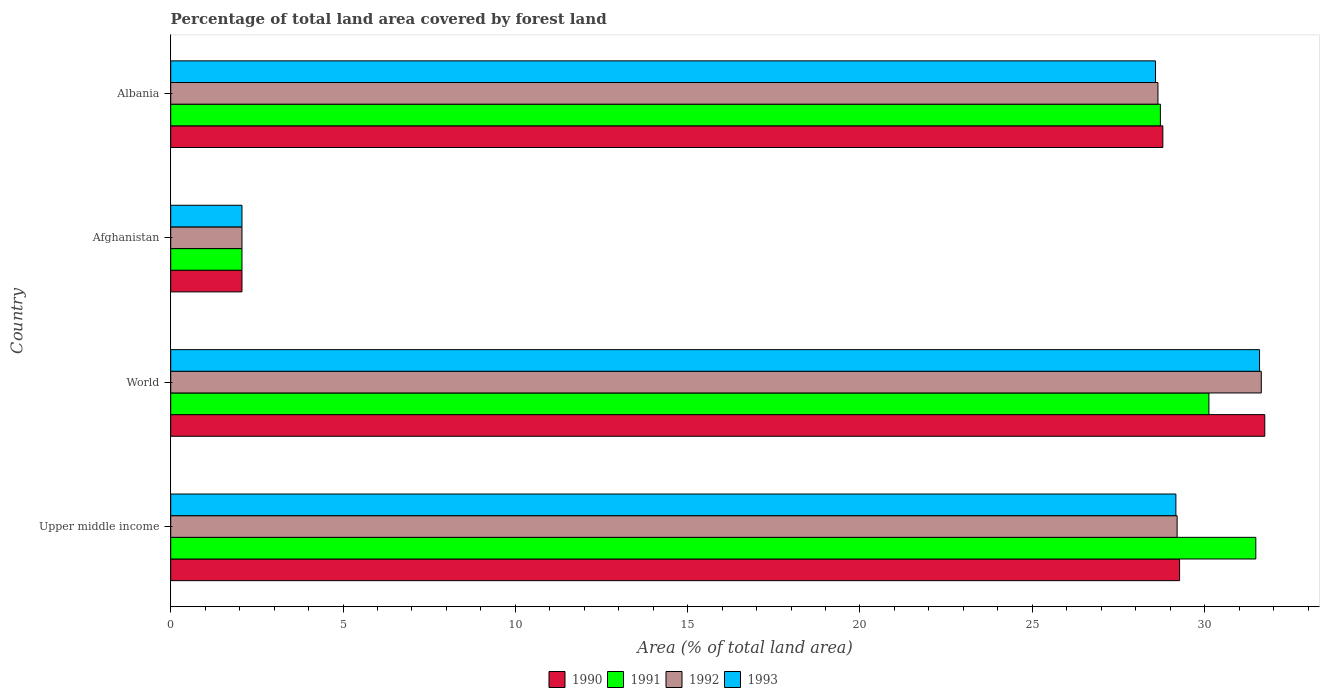How many bars are there on the 1st tick from the bottom?
Keep it short and to the point. 4. What is the label of the 4th group of bars from the top?
Keep it short and to the point. Upper middle income. What is the percentage of forest land in 1992 in World?
Your response must be concise. 31.64. Across all countries, what is the maximum percentage of forest land in 1991?
Ensure brevity in your answer.  31.49. Across all countries, what is the minimum percentage of forest land in 1991?
Give a very brief answer. 2.07. In which country was the percentage of forest land in 1993 maximum?
Provide a short and direct response. World. In which country was the percentage of forest land in 1992 minimum?
Offer a very short reply. Afghanistan. What is the total percentage of forest land in 1993 in the graph?
Keep it short and to the point. 91.4. What is the difference between the percentage of forest land in 1993 in Afghanistan and that in Albania?
Offer a terse response. -26.51. What is the difference between the percentage of forest land in 1992 in Albania and the percentage of forest land in 1991 in World?
Provide a short and direct response. -1.48. What is the average percentage of forest land in 1992 per country?
Your answer should be compact. 22.89. What is the difference between the percentage of forest land in 1991 and percentage of forest land in 1993 in Upper middle income?
Offer a terse response. 2.32. What is the ratio of the percentage of forest land in 1991 in Upper middle income to that in World?
Provide a succinct answer. 1.05. What is the difference between the highest and the second highest percentage of forest land in 1991?
Keep it short and to the point. 1.36. What is the difference between the highest and the lowest percentage of forest land in 1992?
Keep it short and to the point. 29.58. In how many countries, is the percentage of forest land in 1990 greater than the average percentage of forest land in 1990 taken over all countries?
Provide a short and direct response. 3. What does the 1st bar from the top in Afghanistan represents?
Offer a terse response. 1993. What does the 1st bar from the bottom in Albania represents?
Ensure brevity in your answer.  1990. How many bars are there?
Your answer should be very brief. 16. What is the difference between two consecutive major ticks on the X-axis?
Provide a short and direct response. 5. Are the values on the major ticks of X-axis written in scientific E-notation?
Make the answer very short. No. Does the graph contain grids?
Give a very brief answer. No. How are the legend labels stacked?
Your response must be concise. Horizontal. What is the title of the graph?
Offer a very short reply. Percentage of total land area covered by forest land. What is the label or title of the X-axis?
Keep it short and to the point. Area (% of total land area). What is the Area (% of total land area) in 1990 in Upper middle income?
Your answer should be compact. 29.27. What is the Area (% of total land area) in 1991 in Upper middle income?
Provide a short and direct response. 31.49. What is the Area (% of total land area) in 1992 in Upper middle income?
Offer a very short reply. 29.2. What is the Area (% of total land area) of 1993 in Upper middle income?
Give a very brief answer. 29.17. What is the Area (% of total land area) in 1990 in World?
Keep it short and to the point. 31.75. What is the Area (% of total land area) in 1991 in World?
Your answer should be very brief. 30.12. What is the Area (% of total land area) in 1992 in World?
Give a very brief answer. 31.64. What is the Area (% of total land area) of 1993 in World?
Provide a short and direct response. 31.59. What is the Area (% of total land area) of 1990 in Afghanistan?
Your answer should be compact. 2.07. What is the Area (% of total land area) of 1991 in Afghanistan?
Provide a succinct answer. 2.07. What is the Area (% of total land area) in 1992 in Afghanistan?
Give a very brief answer. 2.07. What is the Area (% of total land area) of 1993 in Afghanistan?
Provide a succinct answer. 2.07. What is the Area (% of total land area) in 1990 in Albania?
Offer a terse response. 28.79. What is the Area (% of total land area) in 1991 in Albania?
Offer a very short reply. 28.72. What is the Area (% of total land area) of 1992 in Albania?
Offer a very short reply. 28.65. What is the Area (% of total land area) of 1993 in Albania?
Make the answer very short. 28.57. Across all countries, what is the maximum Area (% of total land area) of 1990?
Provide a short and direct response. 31.75. Across all countries, what is the maximum Area (% of total land area) in 1991?
Offer a very short reply. 31.49. Across all countries, what is the maximum Area (% of total land area) in 1992?
Make the answer very short. 31.64. Across all countries, what is the maximum Area (% of total land area) in 1993?
Your response must be concise. 31.59. Across all countries, what is the minimum Area (% of total land area) in 1990?
Provide a short and direct response. 2.07. Across all countries, what is the minimum Area (% of total land area) in 1991?
Ensure brevity in your answer.  2.07. Across all countries, what is the minimum Area (% of total land area) of 1992?
Offer a very short reply. 2.07. Across all countries, what is the minimum Area (% of total land area) in 1993?
Offer a very short reply. 2.07. What is the total Area (% of total land area) in 1990 in the graph?
Your answer should be very brief. 91.88. What is the total Area (% of total land area) of 1991 in the graph?
Provide a short and direct response. 92.4. What is the total Area (% of total land area) of 1992 in the graph?
Offer a very short reply. 91.56. What is the total Area (% of total land area) of 1993 in the graph?
Offer a very short reply. 91.4. What is the difference between the Area (% of total land area) in 1990 in Upper middle income and that in World?
Make the answer very short. -2.47. What is the difference between the Area (% of total land area) in 1991 in Upper middle income and that in World?
Your answer should be very brief. 1.36. What is the difference between the Area (% of total land area) of 1992 in Upper middle income and that in World?
Offer a very short reply. -2.44. What is the difference between the Area (% of total land area) of 1993 in Upper middle income and that in World?
Make the answer very short. -2.43. What is the difference between the Area (% of total land area) of 1990 in Upper middle income and that in Afghanistan?
Give a very brief answer. 27.21. What is the difference between the Area (% of total land area) of 1991 in Upper middle income and that in Afghanistan?
Offer a terse response. 29.42. What is the difference between the Area (% of total land area) of 1992 in Upper middle income and that in Afghanistan?
Make the answer very short. 27.13. What is the difference between the Area (% of total land area) in 1993 in Upper middle income and that in Afghanistan?
Ensure brevity in your answer.  27.1. What is the difference between the Area (% of total land area) of 1990 in Upper middle income and that in Albania?
Make the answer very short. 0.49. What is the difference between the Area (% of total land area) of 1991 in Upper middle income and that in Albania?
Give a very brief answer. 2.77. What is the difference between the Area (% of total land area) of 1992 in Upper middle income and that in Albania?
Offer a very short reply. 0.56. What is the difference between the Area (% of total land area) in 1993 in Upper middle income and that in Albania?
Provide a succinct answer. 0.59. What is the difference between the Area (% of total land area) in 1990 in World and that in Afghanistan?
Offer a very short reply. 29.68. What is the difference between the Area (% of total land area) of 1991 in World and that in Afghanistan?
Keep it short and to the point. 28.06. What is the difference between the Area (% of total land area) of 1992 in World and that in Afghanistan?
Ensure brevity in your answer.  29.58. What is the difference between the Area (% of total land area) of 1993 in World and that in Afghanistan?
Ensure brevity in your answer.  29.53. What is the difference between the Area (% of total land area) in 1990 in World and that in Albania?
Your answer should be very brief. 2.96. What is the difference between the Area (% of total land area) in 1991 in World and that in Albania?
Offer a terse response. 1.41. What is the difference between the Area (% of total land area) of 1992 in World and that in Albania?
Your response must be concise. 3. What is the difference between the Area (% of total land area) in 1993 in World and that in Albania?
Make the answer very short. 3.02. What is the difference between the Area (% of total land area) in 1990 in Afghanistan and that in Albania?
Keep it short and to the point. -26.72. What is the difference between the Area (% of total land area) in 1991 in Afghanistan and that in Albania?
Offer a terse response. -26.65. What is the difference between the Area (% of total land area) of 1992 in Afghanistan and that in Albania?
Offer a very short reply. -26.58. What is the difference between the Area (% of total land area) in 1993 in Afghanistan and that in Albania?
Provide a short and direct response. -26.51. What is the difference between the Area (% of total land area) in 1990 in Upper middle income and the Area (% of total land area) in 1991 in World?
Your response must be concise. -0.85. What is the difference between the Area (% of total land area) in 1990 in Upper middle income and the Area (% of total land area) in 1992 in World?
Make the answer very short. -2.37. What is the difference between the Area (% of total land area) of 1990 in Upper middle income and the Area (% of total land area) of 1993 in World?
Your response must be concise. -2.32. What is the difference between the Area (% of total land area) in 1991 in Upper middle income and the Area (% of total land area) in 1992 in World?
Offer a very short reply. -0.16. What is the difference between the Area (% of total land area) in 1991 in Upper middle income and the Area (% of total land area) in 1993 in World?
Ensure brevity in your answer.  -0.11. What is the difference between the Area (% of total land area) in 1992 in Upper middle income and the Area (% of total land area) in 1993 in World?
Your answer should be compact. -2.39. What is the difference between the Area (% of total land area) of 1990 in Upper middle income and the Area (% of total land area) of 1991 in Afghanistan?
Your answer should be compact. 27.21. What is the difference between the Area (% of total land area) in 1990 in Upper middle income and the Area (% of total land area) in 1992 in Afghanistan?
Your answer should be compact. 27.21. What is the difference between the Area (% of total land area) of 1990 in Upper middle income and the Area (% of total land area) of 1993 in Afghanistan?
Your answer should be very brief. 27.21. What is the difference between the Area (% of total land area) of 1991 in Upper middle income and the Area (% of total land area) of 1992 in Afghanistan?
Your answer should be compact. 29.42. What is the difference between the Area (% of total land area) of 1991 in Upper middle income and the Area (% of total land area) of 1993 in Afghanistan?
Offer a very short reply. 29.42. What is the difference between the Area (% of total land area) of 1992 in Upper middle income and the Area (% of total land area) of 1993 in Afghanistan?
Your answer should be compact. 27.13. What is the difference between the Area (% of total land area) of 1990 in Upper middle income and the Area (% of total land area) of 1991 in Albania?
Keep it short and to the point. 0.56. What is the difference between the Area (% of total land area) in 1990 in Upper middle income and the Area (% of total land area) in 1992 in Albania?
Your response must be concise. 0.63. What is the difference between the Area (% of total land area) in 1990 in Upper middle income and the Area (% of total land area) in 1993 in Albania?
Give a very brief answer. 0.7. What is the difference between the Area (% of total land area) in 1991 in Upper middle income and the Area (% of total land area) in 1992 in Albania?
Give a very brief answer. 2.84. What is the difference between the Area (% of total land area) in 1991 in Upper middle income and the Area (% of total land area) in 1993 in Albania?
Your answer should be compact. 2.91. What is the difference between the Area (% of total land area) in 1992 in Upper middle income and the Area (% of total land area) in 1993 in Albania?
Keep it short and to the point. 0.63. What is the difference between the Area (% of total land area) of 1990 in World and the Area (% of total land area) of 1991 in Afghanistan?
Your response must be concise. 29.68. What is the difference between the Area (% of total land area) of 1990 in World and the Area (% of total land area) of 1992 in Afghanistan?
Ensure brevity in your answer.  29.68. What is the difference between the Area (% of total land area) in 1990 in World and the Area (% of total land area) in 1993 in Afghanistan?
Your answer should be very brief. 29.68. What is the difference between the Area (% of total land area) of 1991 in World and the Area (% of total land area) of 1992 in Afghanistan?
Offer a terse response. 28.06. What is the difference between the Area (% of total land area) in 1991 in World and the Area (% of total land area) in 1993 in Afghanistan?
Provide a short and direct response. 28.06. What is the difference between the Area (% of total land area) of 1992 in World and the Area (% of total land area) of 1993 in Afghanistan?
Make the answer very short. 29.58. What is the difference between the Area (% of total land area) in 1990 in World and the Area (% of total land area) in 1991 in Albania?
Your response must be concise. 3.03. What is the difference between the Area (% of total land area) of 1990 in World and the Area (% of total land area) of 1992 in Albania?
Keep it short and to the point. 3.1. What is the difference between the Area (% of total land area) in 1990 in World and the Area (% of total land area) in 1993 in Albania?
Your response must be concise. 3.17. What is the difference between the Area (% of total land area) of 1991 in World and the Area (% of total land area) of 1992 in Albania?
Give a very brief answer. 1.48. What is the difference between the Area (% of total land area) in 1991 in World and the Area (% of total land area) in 1993 in Albania?
Give a very brief answer. 1.55. What is the difference between the Area (% of total land area) of 1992 in World and the Area (% of total land area) of 1993 in Albania?
Offer a very short reply. 3.07. What is the difference between the Area (% of total land area) in 1990 in Afghanistan and the Area (% of total land area) in 1991 in Albania?
Ensure brevity in your answer.  -26.65. What is the difference between the Area (% of total land area) in 1990 in Afghanistan and the Area (% of total land area) in 1992 in Albania?
Your answer should be very brief. -26.58. What is the difference between the Area (% of total land area) of 1990 in Afghanistan and the Area (% of total land area) of 1993 in Albania?
Provide a succinct answer. -26.51. What is the difference between the Area (% of total land area) in 1991 in Afghanistan and the Area (% of total land area) in 1992 in Albania?
Ensure brevity in your answer.  -26.58. What is the difference between the Area (% of total land area) in 1991 in Afghanistan and the Area (% of total land area) in 1993 in Albania?
Offer a terse response. -26.51. What is the difference between the Area (% of total land area) of 1992 in Afghanistan and the Area (% of total land area) of 1993 in Albania?
Offer a very short reply. -26.51. What is the average Area (% of total land area) in 1990 per country?
Your answer should be compact. 22.97. What is the average Area (% of total land area) in 1991 per country?
Make the answer very short. 23.1. What is the average Area (% of total land area) of 1992 per country?
Keep it short and to the point. 22.89. What is the average Area (% of total land area) in 1993 per country?
Provide a succinct answer. 22.85. What is the difference between the Area (% of total land area) in 1990 and Area (% of total land area) in 1991 in Upper middle income?
Give a very brief answer. -2.21. What is the difference between the Area (% of total land area) in 1990 and Area (% of total land area) in 1992 in Upper middle income?
Give a very brief answer. 0.07. What is the difference between the Area (% of total land area) in 1990 and Area (% of total land area) in 1993 in Upper middle income?
Give a very brief answer. 0.11. What is the difference between the Area (% of total land area) in 1991 and Area (% of total land area) in 1992 in Upper middle income?
Your answer should be very brief. 2.28. What is the difference between the Area (% of total land area) in 1991 and Area (% of total land area) in 1993 in Upper middle income?
Your answer should be very brief. 2.32. What is the difference between the Area (% of total land area) in 1992 and Area (% of total land area) in 1993 in Upper middle income?
Your answer should be compact. 0.04. What is the difference between the Area (% of total land area) in 1990 and Area (% of total land area) in 1991 in World?
Keep it short and to the point. 1.62. What is the difference between the Area (% of total land area) of 1990 and Area (% of total land area) of 1992 in World?
Provide a succinct answer. 0.1. What is the difference between the Area (% of total land area) of 1990 and Area (% of total land area) of 1993 in World?
Your response must be concise. 0.15. What is the difference between the Area (% of total land area) of 1991 and Area (% of total land area) of 1992 in World?
Make the answer very short. -1.52. What is the difference between the Area (% of total land area) in 1991 and Area (% of total land area) in 1993 in World?
Ensure brevity in your answer.  -1.47. What is the difference between the Area (% of total land area) in 1992 and Area (% of total land area) in 1993 in World?
Offer a very short reply. 0.05. What is the difference between the Area (% of total land area) in 1990 and Area (% of total land area) in 1991 in Afghanistan?
Give a very brief answer. 0. What is the difference between the Area (% of total land area) of 1990 and Area (% of total land area) of 1992 in Afghanistan?
Keep it short and to the point. 0. What is the difference between the Area (% of total land area) of 1990 and Area (% of total land area) of 1993 in Afghanistan?
Offer a terse response. 0. What is the difference between the Area (% of total land area) of 1991 and Area (% of total land area) of 1992 in Afghanistan?
Provide a succinct answer. 0. What is the difference between the Area (% of total land area) in 1992 and Area (% of total land area) in 1993 in Afghanistan?
Offer a very short reply. 0. What is the difference between the Area (% of total land area) of 1990 and Area (% of total land area) of 1991 in Albania?
Make the answer very short. 0.07. What is the difference between the Area (% of total land area) in 1990 and Area (% of total land area) in 1992 in Albania?
Offer a very short reply. 0.14. What is the difference between the Area (% of total land area) of 1990 and Area (% of total land area) of 1993 in Albania?
Offer a terse response. 0.21. What is the difference between the Area (% of total land area) of 1991 and Area (% of total land area) of 1992 in Albania?
Your answer should be compact. 0.07. What is the difference between the Area (% of total land area) of 1991 and Area (% of total land area) of 1993 in Albania?
Provide a succinct answer. 0.14. What is the difference between the Area (% of total land area) of 1992 and Area (% of total land area) of 1993 in Albania?
Your answer should be very brief. 0.07. What is the ratio of the Area (% of total land area) of 1990 in Upper middle income to that in World?
Your answer should be compact. 0.92. What is the ratio of the Area (% of total land area) in 1991 in Upper middle income to that in World?
Your answer should be compact. 1.05. What is the ratio of the Area (% of total land area) in 1992 in Upper middle income to that in World?
Provide a succinct answer. 0.92. What is the ratio of the Area (% of total land area) in 1993 in Upper middle income to that in World?
Make the answer very short. 0.92. What is the ratio of the Area (% of total land area) in 1990 in Upper middle income to that in Afghanistan?
Keep it short and to the point. 14.16. What is the ratio of the Area (% of total land area) of 1991 in Upper middle income to that in Afghanistan?
Your answer should be compact. 15.23. What is the ratio of the Area (% of total land area) of 1992 in Upper middle income to that in Afghanistan?
Your answer should be very brief. 14.12. What is the ratio of the Area (% of total land area) in 1993 in Upper middle income to that in Afghanistan?
Your answer should be compact. 14.11. What is the ratio of the Area (% of total land area) of 1990 in Upper middle income to that in Albania?
Offer a terse response. 1.02. What is the ratio of the Area (% of total land area) of 1991 in Upper middle income to that in Albania?
Your answer should be very brief. 1.1. What is the ratio of the Area (% of total land area) of 1992 in Upper middle income to that in Albania?
Your response must be concise. 1.02. What is the ratio of the Area (% of total land area) in 1993 in Upper middle income to that in Albania?
Your answer should be very brief. 1.02. What is the ratio of the Area (% of total land area) in 1990 in World to that in Afghanistan?
Keep it short and to the point. 15.35. What is the ratio of the Area (% of total land area) in 1991 in World to that in Afghanistan?
Give a very brief answer. 14.57. What is the ratio of the Area (% of total land area) in 1992 in World to that in Afghanistan?
Make the answer very short. 15.3. What is the ratio of the Area (% of total land area) of 1993 in World to that in Afghanistan?
Your answer should be very brief. 15.28. What is the ratio of the Area (% of total land area) in 1990 in World to that in Albania?
Give a very brief answer. 1.1. What is the ratio of the Area (% of total land area) in 1991 in World to that in Albania?
Provide a succinct answer. 1.05. What is the ratio of the Area (% of total land area) of 1992 in World to that in Albania?
Your response must be concise. 1.1. What is the ratio of the Area (% of total land area) of 1993 in World to that in Albania?
Provide a succinct answer. 1.11. What is the ratio of the Area (% of total land area) in 1990 in Afghanistan to that in Albania?
Offer a very short reply. 0.07. What is the ratio of the Area (% of total land area) in 1991 in Afghanistan to that in Albania?
Give a very brief answer. 0.07. What is the ratio of the Area (% of total land area) in 1992 in Afghanistan to that in Albania?
Ensure brevity in your answer.  0.07. What is the ratio of the Area (% of total land area) of 1993 in Afghanistan to that in Albania?
Provide a succinct answer. 0.07. What is the difference between the highest and the second highest Area (% of total land area) in 1990?
Your answer should be very brief. 2.47. What is the difference between the highest and the second highest Area (% of total land area) in 1991?
Offer a very short reply. 1.36. What is the difference between the highest and the second highest Area (% of total land area) of 1992?
Make the answer very short. 2.44. What is the difference between the highest and the second highest Area (% of total land area) of 1993?
Offer a terse response. 2.43. What is the difference between the highest and the lowest Area (% of total land area) of 1990?
Make the answer very short. 29.68. What is the difference between the highest and the lowest Area (% of total land area) in 1991?
Ensure brevity in your answer.  29.42. What is the difference between the highest and the lowest Area (% of total land area) in 1992?
Offer a terse response. 29.58. What is the difference between the highest and the lowest Area (% of total land area) of 1993?
Your response must be concise. 29.53. 